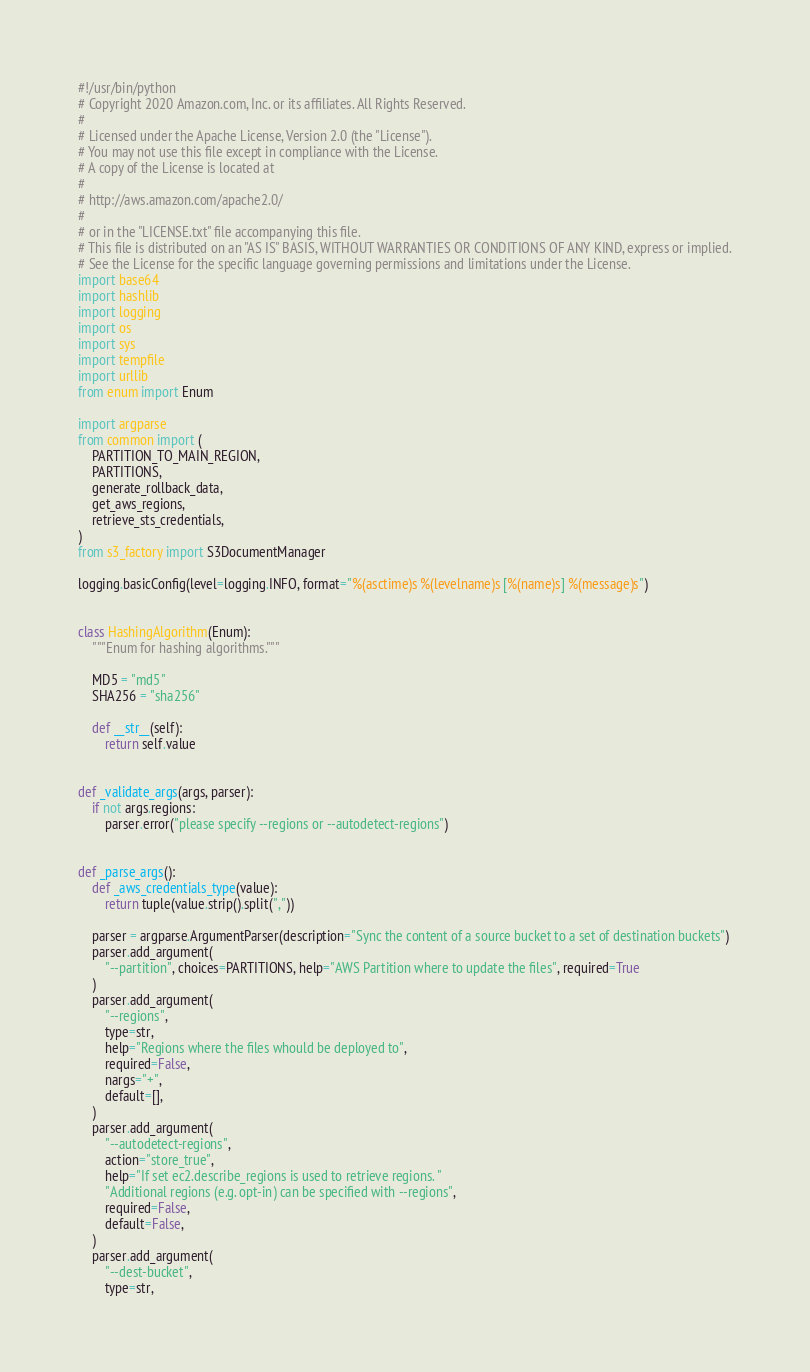Convert code to text. <code><loc_0><loc_0><loc_500><loc_500><_Python_>#!/usr/bin/python
# Copyright 2020 Amazon.com, Inc. or its affiliates. All Rights Reserved.
#
# Licensed under the Apache License, Version 2.0 (the "License").
# You may not use this file except in compliance with the License.
# A copy of the License is located at
#
# http://aws.amazon.com/apache2.0/
#
# or in the "LICENSE.txt" file accompanying this file.
# This file is distributed on an "AS IS" BASIS, WITHOUT WARRANTIES OR CONDITIONS OF ANY KIND, express or implied.
# See the License for the specific language governing permissions and limitations under the License.
import base64
import hashlib
import logging
import os
import sys
import tempfile
import urllib
from enum import Enum

import argparse
from common import (
    PARTITION_TO_MAIN_REGION,
    PARTITIONS,
    generate_rollback_data,
    get_aws_regions,
    retrieve_sts_credentials,
)
from s3_factory import S3DocumentManager

logging.basicConfig(level=logging.INFO, format="%(asctime)s %(levelname)s [%(name)s] %(message)s")


class HashingAlgorithm(Enum):
    """Enum for hashing algorithms."""

    MD5 = "md5"
    SHA256 = "sha256"

    def __str__(self):
        return self.value


def _validate_args(args, parser):
    if not args.regions:
        parser.error("please specify --regions or --autodetect-regions")


def _parse_args():
    def _aws_credentials_type(value):
        return tuple(value.strip().split(","))

    parser = argparse.ArgumentParser(description="Sync the content of a source bucket to a set of destination buckets")
    parser.add_argument(
        "--partition", choices=PARTITIONS, help="AWS Partition where to update the files", required=True
    )
    parser.add_argument(
        "--regions",
        type=str,
        help="Regions where the files whould be deployed to",
        required=False,
        nargs="+",
        default=[],
    )
    parser.add_argument(
        "--autodetect-regions",
        action="store_true",
        help="If set ec2.describe_regions is used to retrieve regions. "
        "Additional regions (e.g. opt-in) can be specified with --regions",
        required=False,
        default=False,
    )
    parser.add_argument(
        "--dest-bucket",
        type=str,</code> 